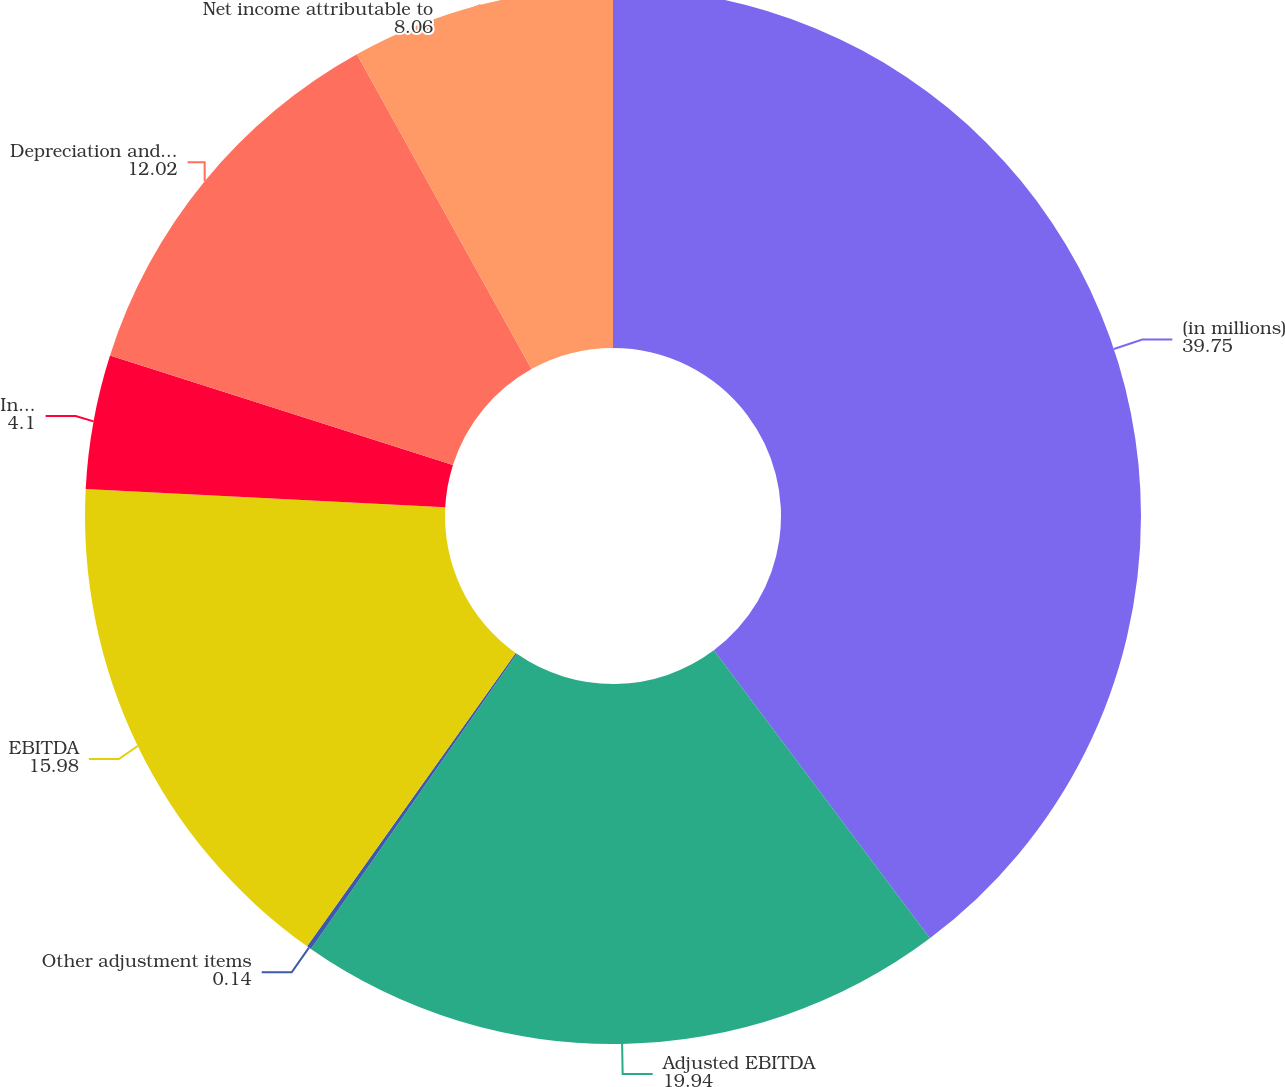Convert chart to OTSL. <chart><loc_0><loc_0><loc_500><loc_500><pie_chart><fcel>(in millions)<fcel>Adjusted EBITDA<fcel>Other adjustment items<fcel>EBITDA<fcel>Income tax expense<fcel>Depreciation and amortization<fcel>Net income attributable to<nl><fcel>39.75%<fcel>19.94%<fcel>0.14%<fcel>15.98%<fcel>4.1%<fcel>12.02%<fcel>8.06%<nl></chart> 